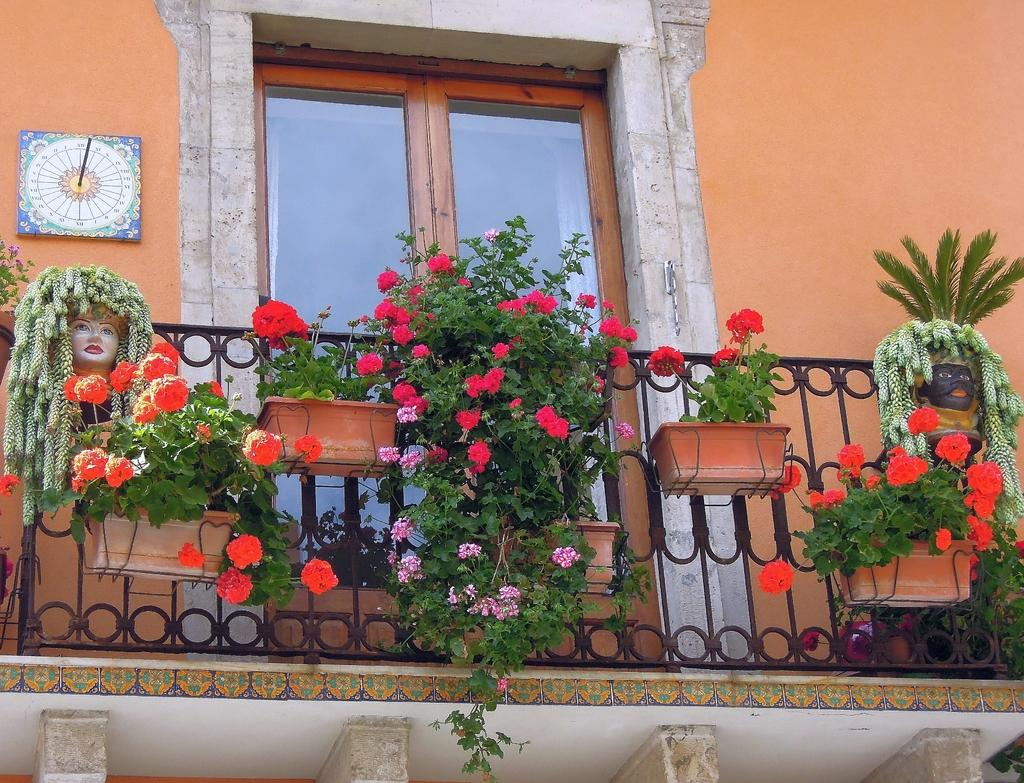What type of objects are hanging on the iron grilles in the image? There are flower pots with plants and flowers hanging on the iron grilles in the image. What is the purpose of the iron grilles in the image? The iron grilles are used to support and display the flower pots with plants and flowers. What is the main feature of the door in the image? The door in the image is a standard door, likely used for entering or exiting a room or building. What is attached to the wall in the image? There is an object attached to the wall in the image, but the specific nature of the object is not mentioned in the provided facts. What type of bedroom furniture can be seen in the image? There is no bedroom furniture present in the image; it features flower pots with plants and flowers hanging on iron grilles, a door, and an object attached to the wall. What type of act is being performed by the plants in the image? The plants in the image are not performing any act; they are simply growing in the flower pots. 